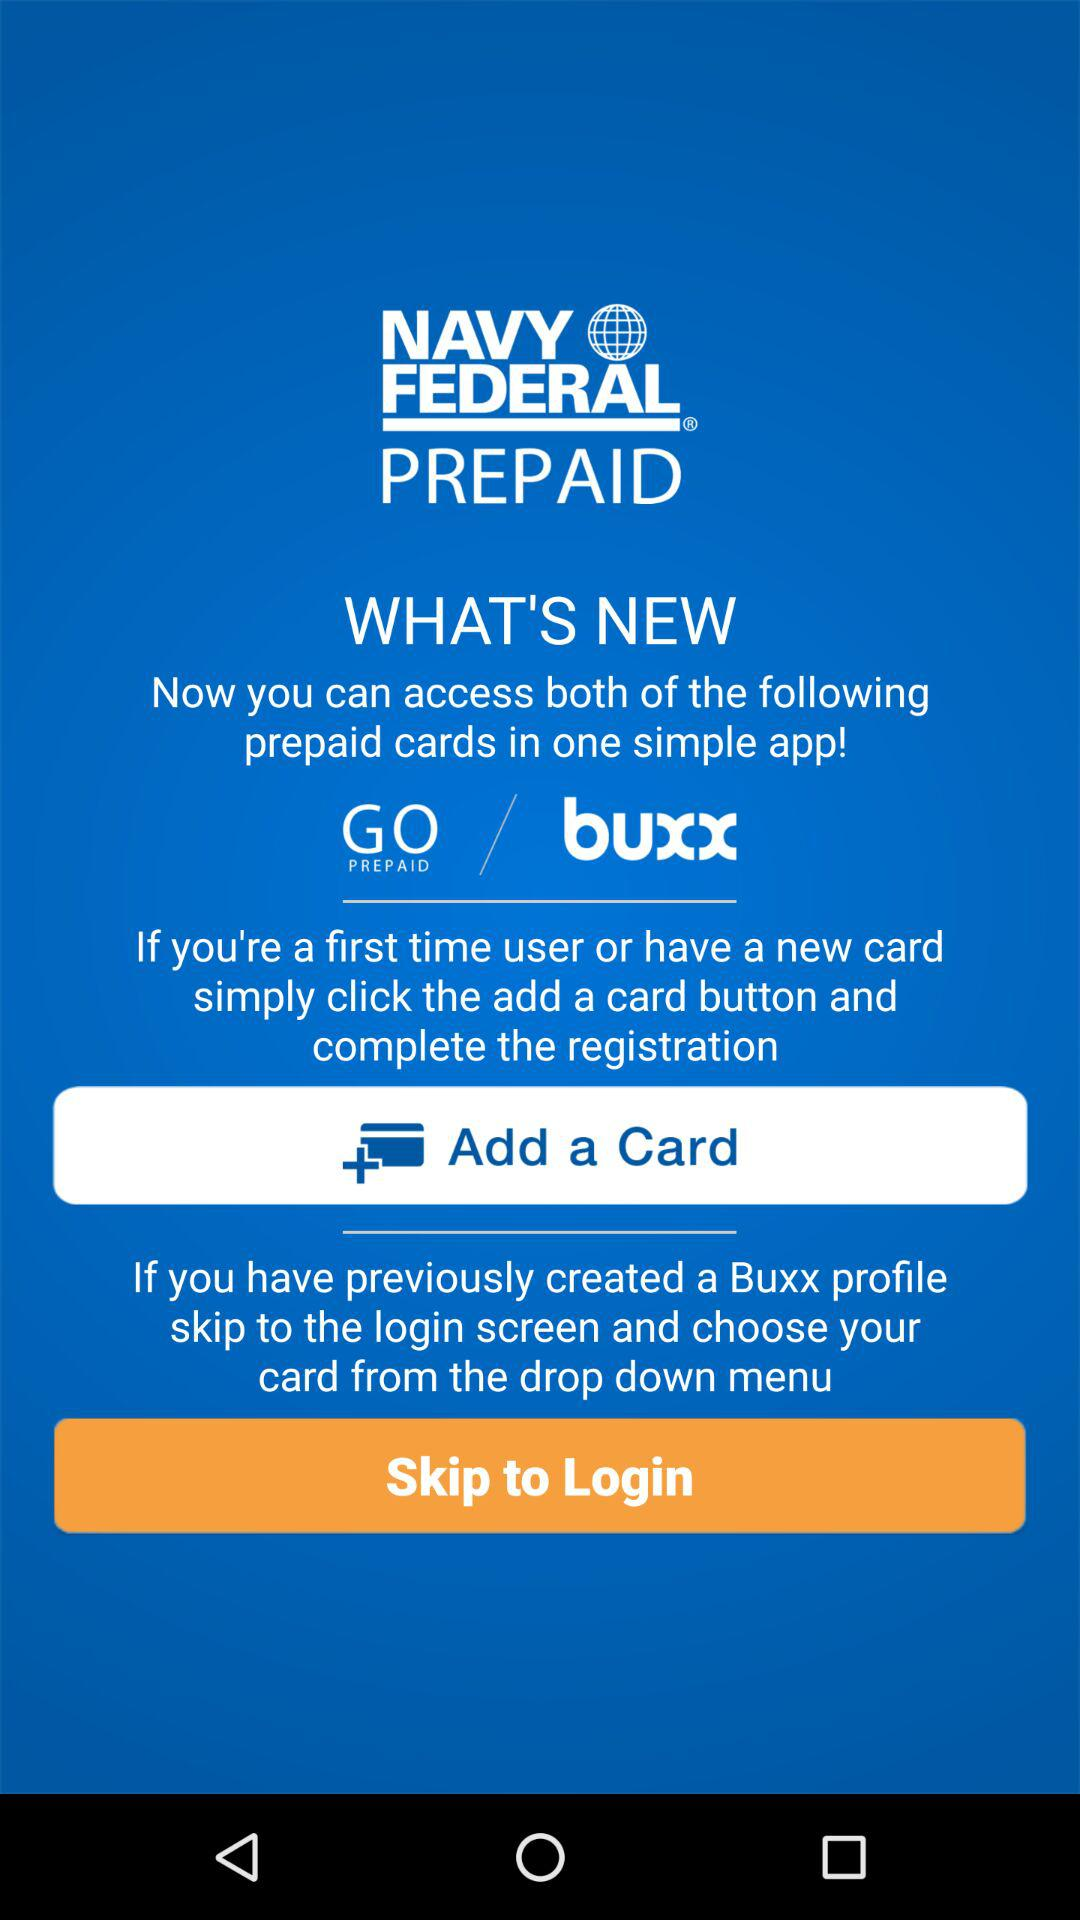How many different ways can I access my cards?
Answer the question using a single word or phrase. 2 